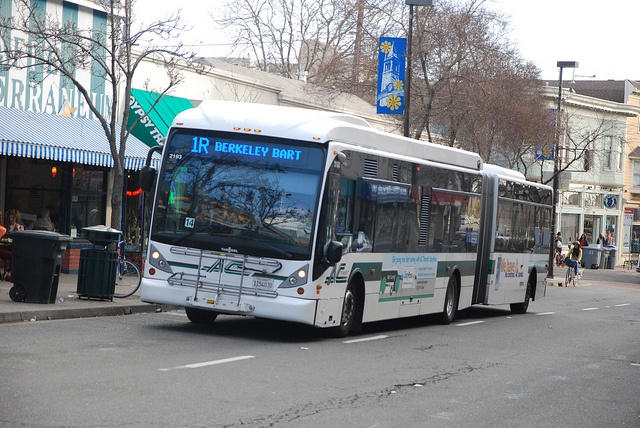Describe the objects in this image and their specific colors. I can see bus in gray, black, darkgray, and lightgray tones, bicycle in gray, darkgray, and black tones, people in gray and black tones, people in gray, black, maroon, and brown tones, and people in gray, black, and maroon tones in this image. 